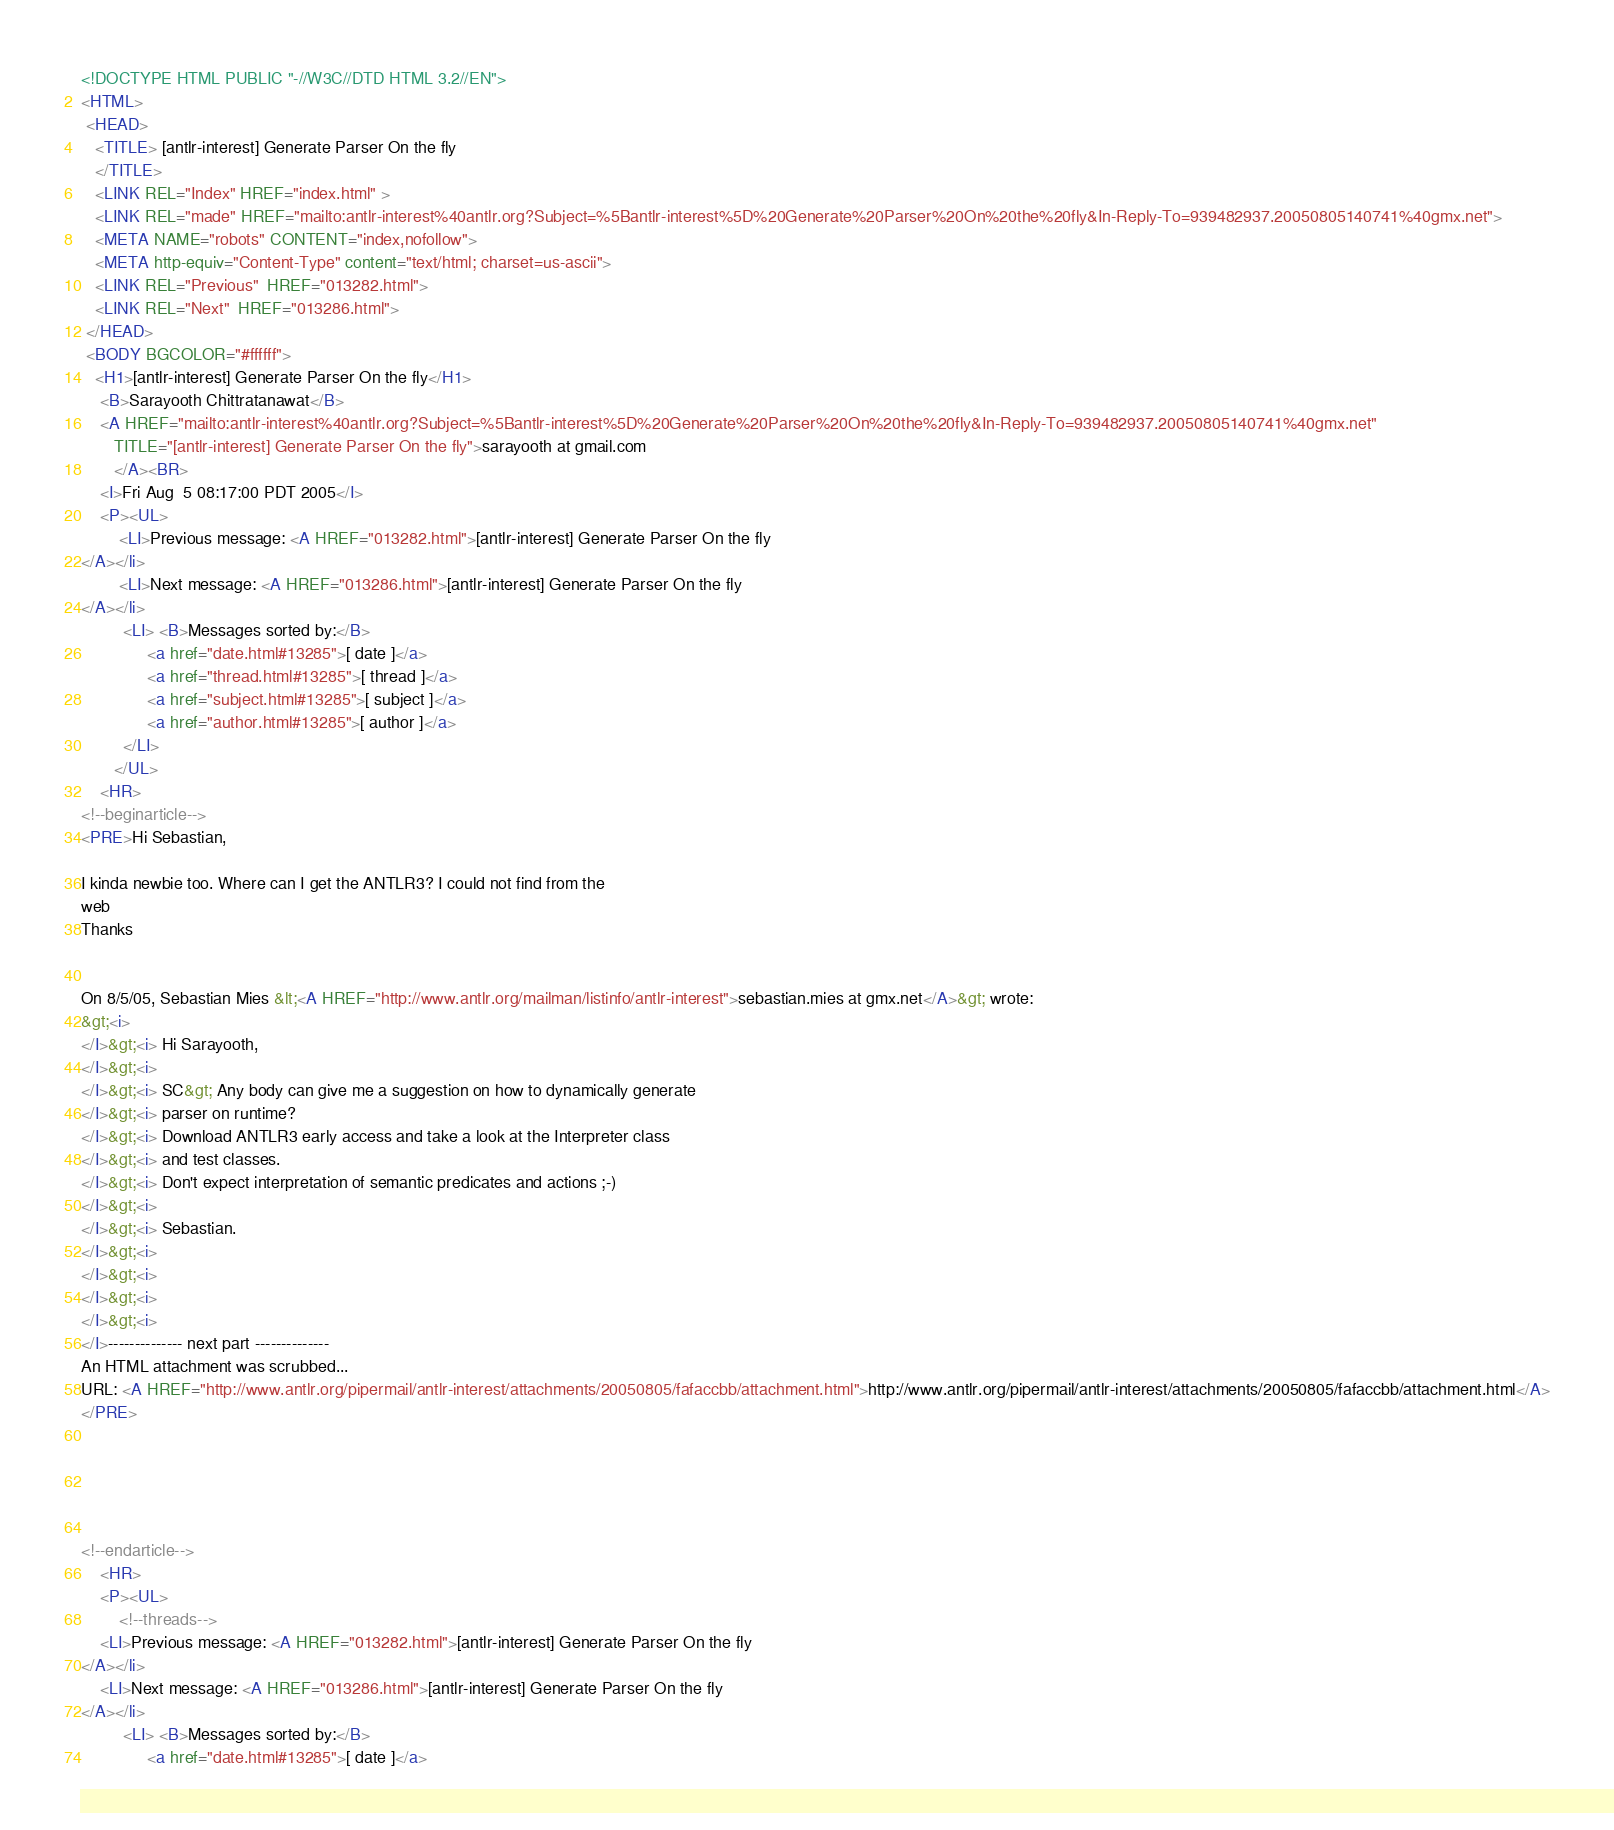<code> <loc_0><loc_0><loc_500><loc_500><_HTML_><!DOCTYPE HTML PUBLIC "-//W3C//DTD HTML 3.2//EN">
<HTML>
 <HEAD>
   <TITLE> [antlr-interest] Generate Parser On the fly
   </TITLE>
   <LINK REL="Index" HREF="index.html" >
   <LINK REL="made" HREF="mailto:antlr-interest%40antlr.org?Subject=%5Bantlr-interest%5D%20Generate%20Parser%20On%20the%20fly&In-Reply-To=939482937.20050805140741%40gmx.net">
   <META NAME="robots" CONTENT="index,nofollow">
   <META http-equiv="Content-Type" content="text/html; charset=us-ascii">
   <LINK REL="Previous"  HREF="013282.html">
   <LINK REL="Next"  HREF="013286.html">
 </HEAD>
 <BODY BGCOLOR="#ffffff">
   <H1>[antlr-interest] Generate Parser On the fly</H1>
    <B>Sarayooth Chittratanawat</B> 
    <A HREF="mailto:antlr-interest%40antlr.org?Subject=%5Bantlr-interest%5D%20Generate%20Parser%20On%20the%20fly&In-Reply-To=939482937.20050805140741%40gmx.net"
       TITLE="[antlr-interest] Generate Parser On the fly">sarayooth at gmail.com
       </A><BR>
    <I>Fri Aug  5 08:17:00 PDT 2005</I>
    <P><UL>
        <LI>Previous message: <A HREF="013282.html">[antlr-interest] Generate Parser On the fly
</A></li>
        <LI>Next message: <A HREF="013286.html">[antlr-interest] Generate Parser On the fly
</A></li>
         <LI> <B>Messages sorted by:</B> 
              <a href="date.html#13285">[ date ]</a>
              <a href="thread.html#13285">[ thread ]</a>
              <a href="subject.html#13285">[ subject ]</a>
              <a href="author.html#13285">[ author ]</a>
         </LI>
       </UL>
    <HR>  
<!--beginarticle-->
<PRE>Hi Sebastian,

I kinda newbie too. Where can I get the ANTLR3? I could not find from the 
web
Thanks


On 8/5/05, Sebastian Mies &lt;<A HREF="http://www.antlr.org/mailman/listinfo/antlr-interest">sebastian.mies at gmx.net</A>&gt; wrote:
&gt;<i> 
</I>&gt;<i> Hi Sarayooth,
</I>&gt;<i> 
</I>&gt;<i> SC&gt; Any body can give me a suggestion on how to dynamically generate 
</I>&gt;<i> parser on runtime?
</I>&gt;<i> Download ANTLR3 early access and take a look at the Interpreter class
</I>&gt;<i> and test classes.
</I>&gt;<i> Don't expect interpretation of semantic predicates and actions ;-)
</I>&gt;<i> 
</I>&gt;<i> Sebastian.
</I>&gt;<i> 
</I>&gt;<i> 
</I>&gt;<i> 
</I>&gt;<i>
</I>-------------- next part --------------
An HTML attachment was scrubbed...
URL: <A HREF="http://www.antlr.org/pipermail/antlr-interest/attachments/20050805/fafaccbb/attachment.html">http://www.antlr.org/pipermail/antlr-interest/attachments/20050805/fafaccbb/attachment.html</A>
</PRE>





<!--endarticle-->
    <HR>
    <P><UL>
        <!--threads-->
	<LI>Previous message: <A HREF="013282.html">[antlr-interest] Generate Parser On the fly
</A></li>
	<LI>Next message: <A HREF="013286.html">[antlr-interest] Generate Parser On the fly
</A></li>
         <LI> <B>Messages sorted by:</B> 
              <a href="date.html#13285">[ date ]</a></code> 